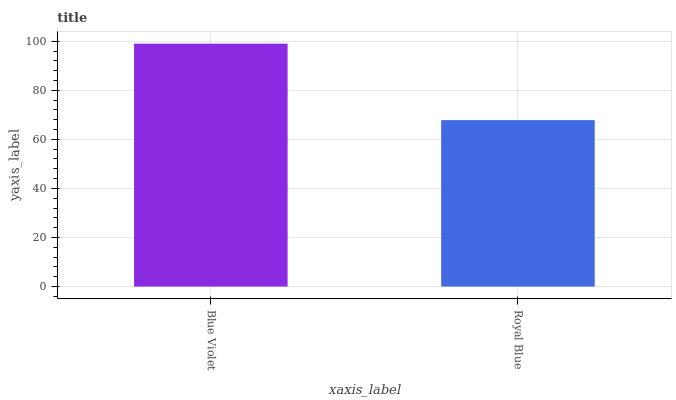Is Royal Blue the minimum?
Answer yes or no. Yes. Is Blue Violet the maximum?
Answer yes or no. Yes. Is Royal Blue the maximum?
Answer yes or no. No. Is Blue Violet greater than Royal Blue?
Answer yes or no. Yes. Is Royal Blue less than Blue Violet?
Answer yes or no. Yes. Is Royal Blue greater than Blue Violet?
Answer yes or no. No. Is Blue Violet less than Royal Blue?
Answer yes or no. No. Is Blue Violet the high median?
Answer yes or no. Yes. Is Royal Blue the low median?
Answer yes or no. Yes. Is Royal Blue the high median?
Answer yes or no. No. Is Blue Violet the low median?
Answer yes or no. No. 